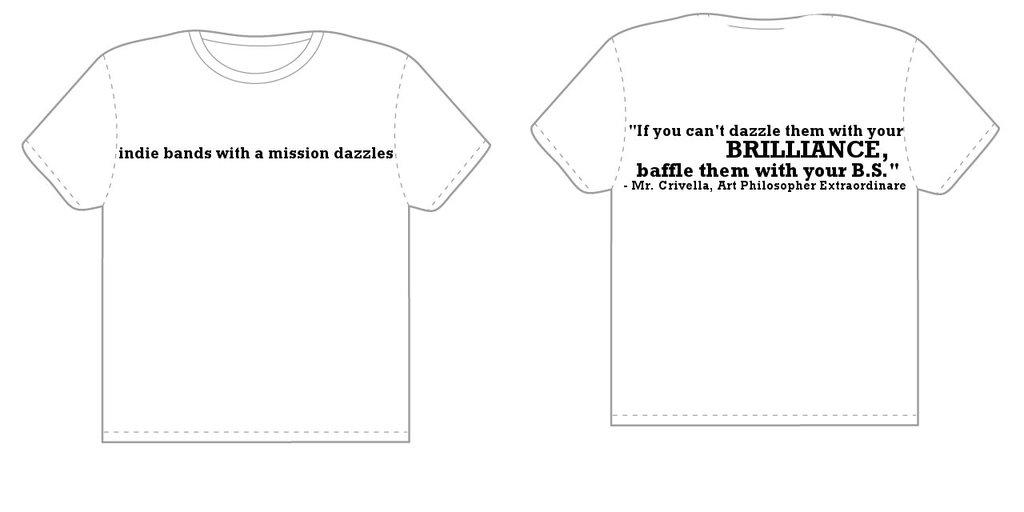Provide a one-sentence caption for the provided image. Tee shirt blueprints with information about indie bands on them. 